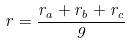Convert formula to latex. <formula><loc_0><loc_0><loc_500><loc_500>r = \frac { r _ { a } + r _ { b } + r _ { c } } { 9 }</formula> 